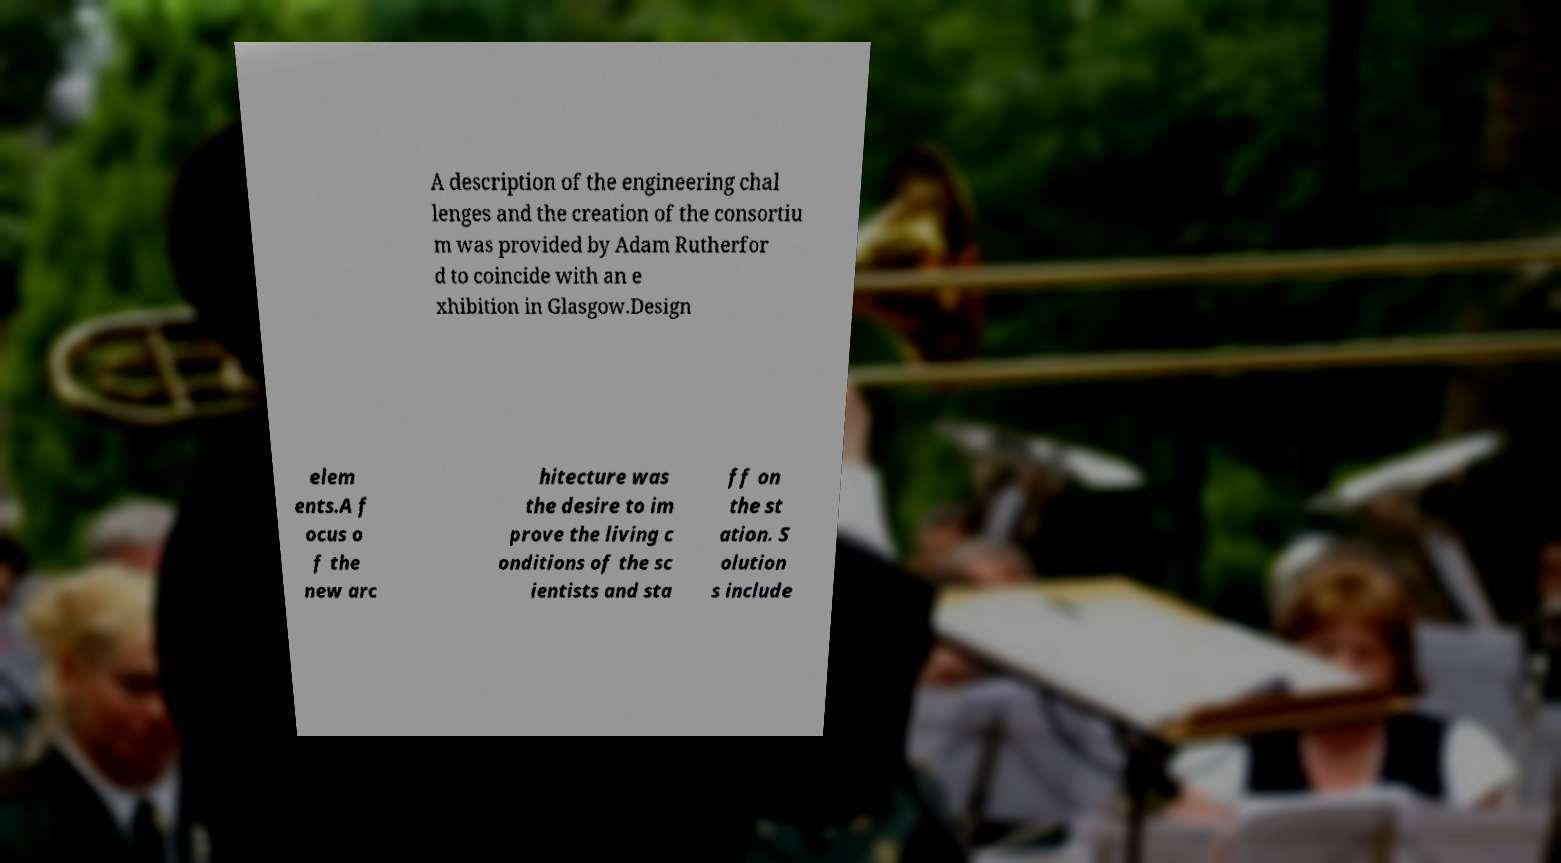There's text embedded in this image that I need extracted. Can you transcribe it verbatim? A description of the engineering chal lenges and the creation of the consortiu m was provided by Adam Rutherfor d to coincide with an e xhibition in Glasgow.Design elem ents.A f ocus o f the new arc hitecture was the desire to im prove the living c onditions of the sc ientists and sta ff on the st ation. S olution s include 